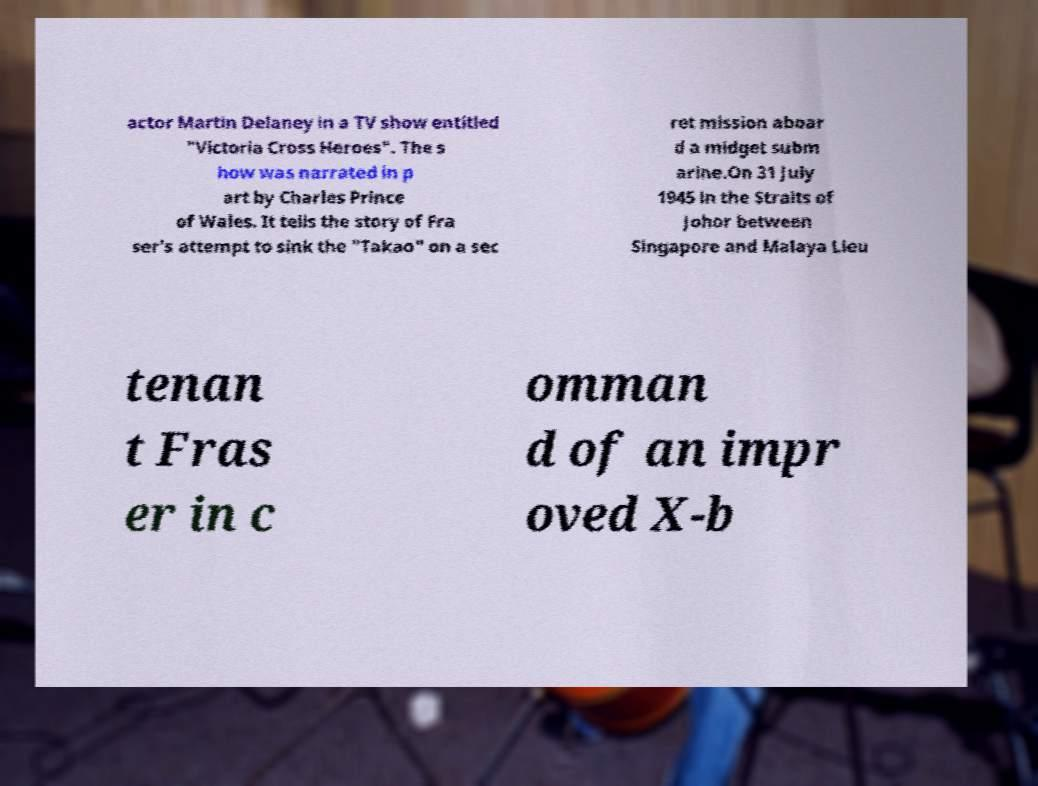Can you accurately transcribe the text from the provided image for me? actor Martin Delaney in a TV show entitled "Victoria Cross Heroes". The s how was narrated in p art by Charles Prince of Wales. It tells the story of Fra ser's attempt to sink the "Takao" on a sec ret mission aboar d a midget subm arine.On 31 July 1945 in the Straits of Johor between Singapore and Malaya Lieu tenan t Fras er in c omman d of an impr oved X-b 